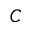Convert formula to latex. <formula><loc_0><loc_0><loc_500><loc_500>C</formula> 